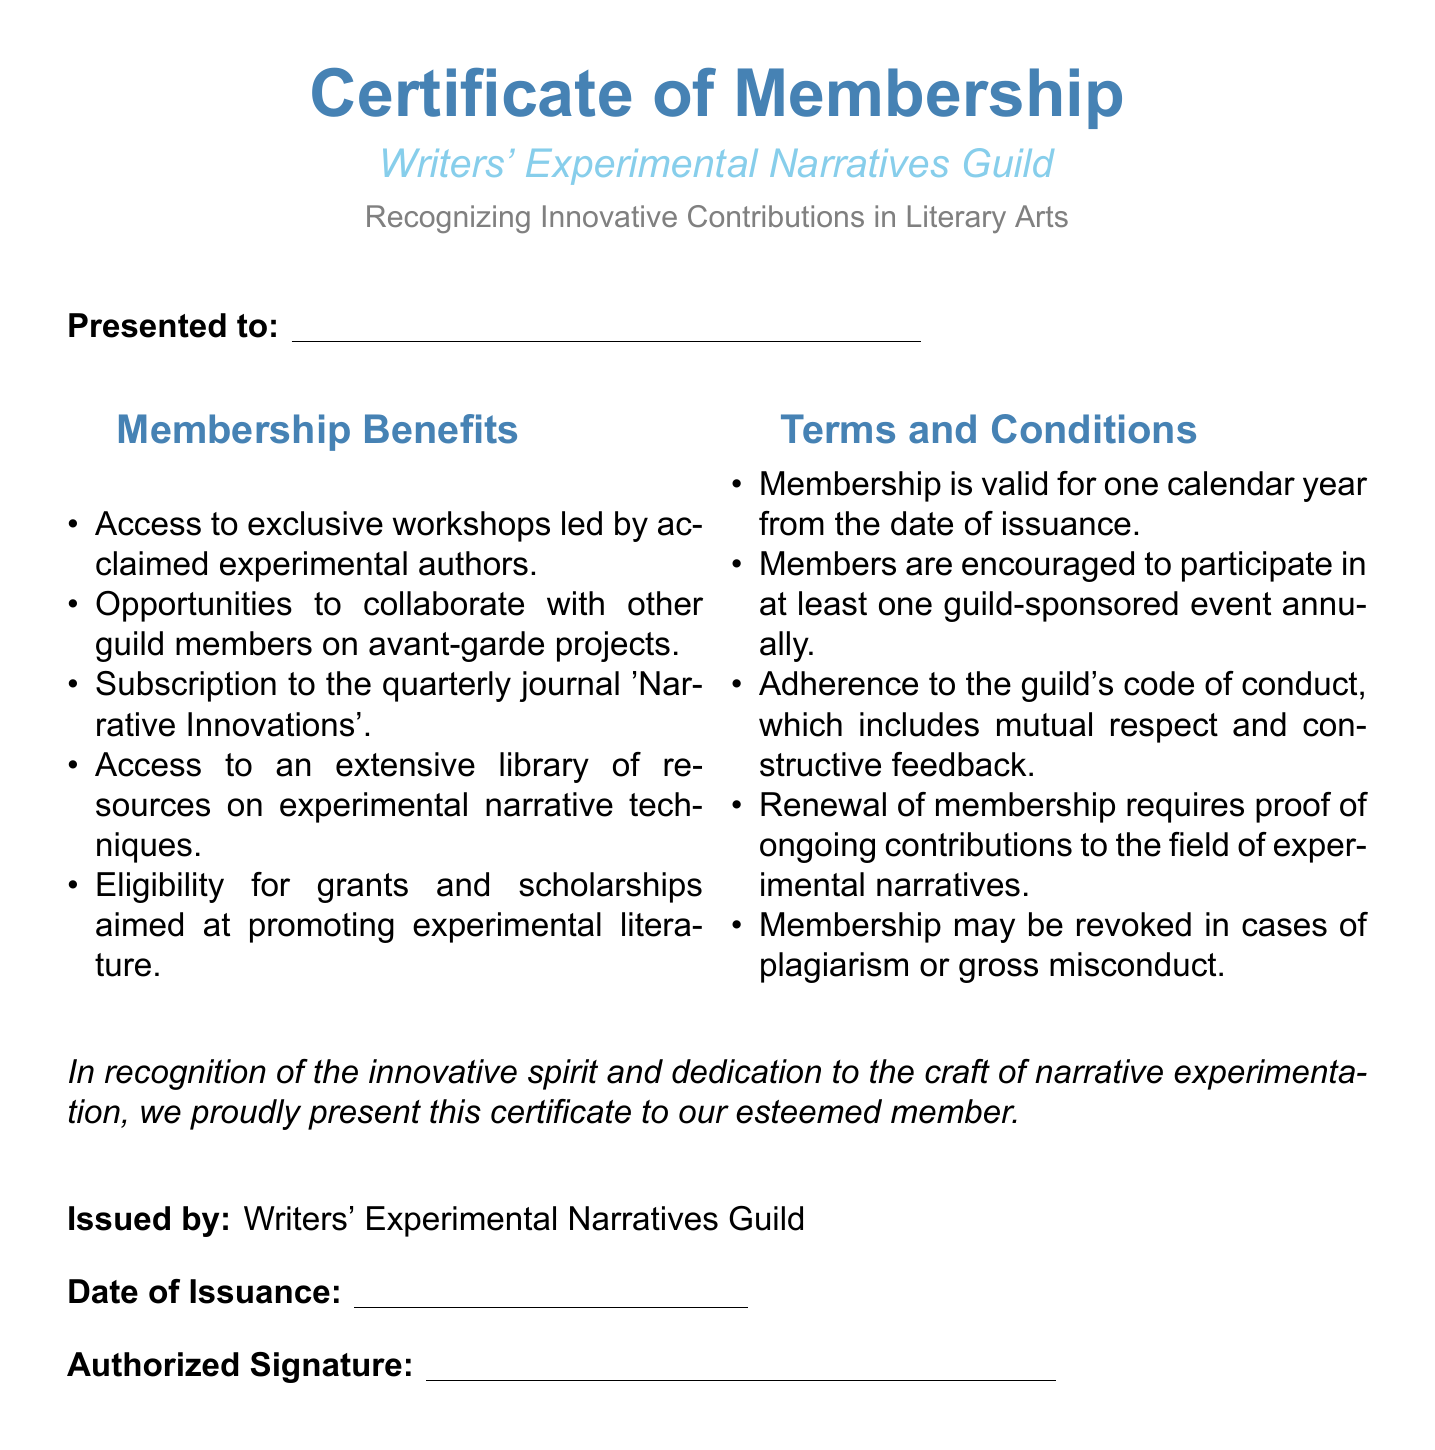what is the name of the guild? The name of the guild is mentioned clearly at the top of the certificate.
Answer: Writers' Experimental Narratives Guild what does the certificate recognize? The certificate states its purpose below the title in a descriptive manner.
Answer: Innovative Contributions in Literary Arts how long is the membership validity? The terms and conditions specify the duration of the membership.
Answer: One calendar year what is required for membership renewal? The terms specify a condition that must be met for renewal of membership.
Answer: Proof of ongoing contributions what are members encouraged to do annually? The conditions highlight a specific participation encouragement for members.
Answer: Participate in one guild-sponsored event what is one benefit of membership? The membership benefits section lists advantages of being part of the guild.
Answer: Access to exclusive workshops who issues the certificate? The document clearly states who presented the certificate at the end.
Answer: Writers' Experimental Narratives Guild what must members adhere to as part of the code of conduct? The terms outline a fundamental expectation regarding interactions among members.
Answer: Mutual respect what is the title of the quarterly journal? The benefits section includes the name of the publication members receive.
Answer: Narrative Innovations 